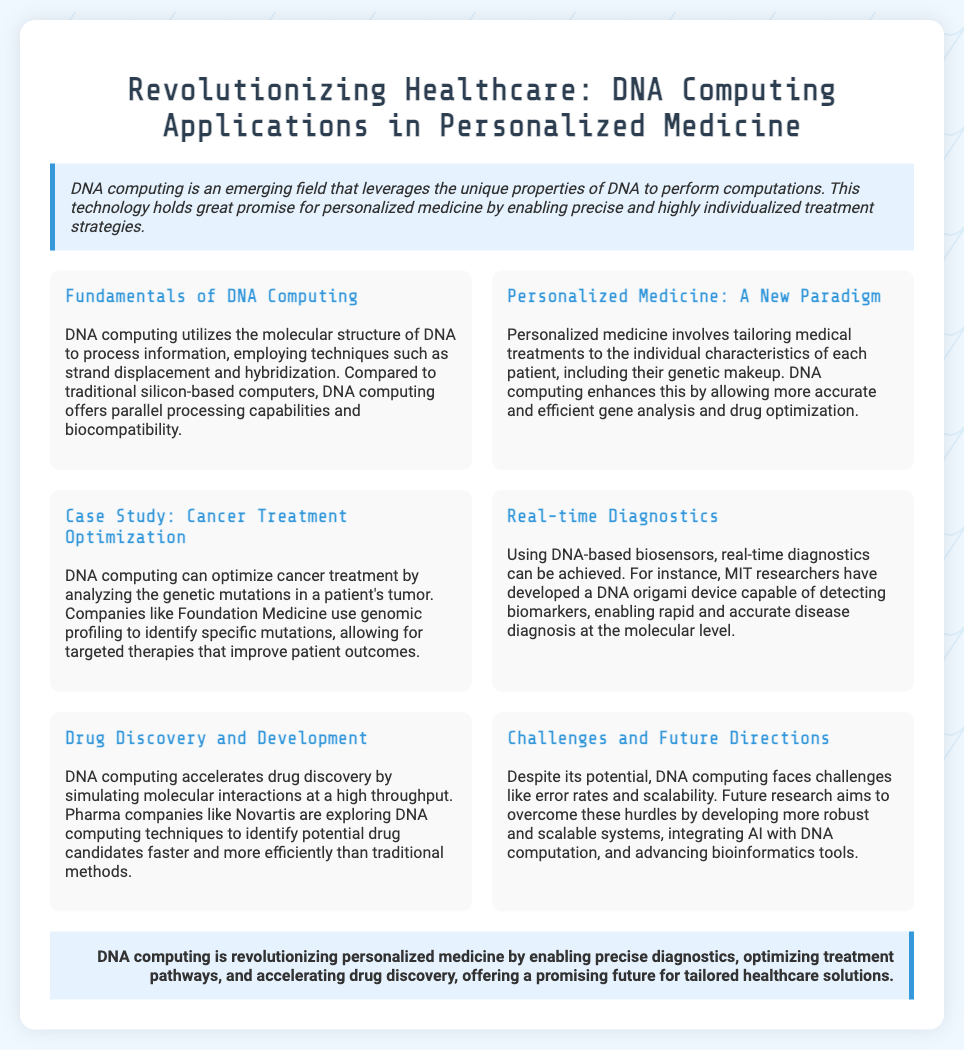What is DNA computing? DNA computing is an emerging field that leverages the unique properties of DNA to perform computations.
Answer: An emerging field What enhances personalized medicine according to the document? DNA computing enhances personalized medicine by allowing more accurate and efficient gene analysis and drug optimization.
Answer: More accurate and efficient gene analysis Which company is mentioned in optimizing cancer treatment? The slide mentions Foundation Medicine as a company using genomic profiling to identify specific mutations.
Answer: Foundation Medicine What is the purpose of DNA-based biosensors? DNA-based biosensors enable rapid and accurate disease diagnosis at the molecular level.
Answer: Rapid and accurate disease diagnosis What challenge does DNA computing face? The document mentions error rates and scalability as challenges that DNA computing faces.
Answer: Error rates and scalability What is one application of DNA computing in drug discovery? DNA computing accelerates drug discovery by simulating molecular interactions at a high throughput.
Answer: Simulating molecular interactions What is the conclusion about DNA computing's impact on healthcare? The conclusion emphasizes that DNA computing is revolutionizing personalized medicine by enabling precise diagnostics and optimizing treatment pathways.
Answer: Revolutionizing personalized medicine Who developed a DNA origami device? MIT researchers are credited with developing a DNA origami device for disease diagnostics.
Answer: MIT researchers 